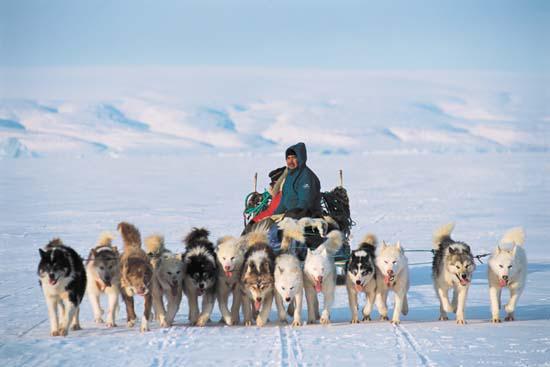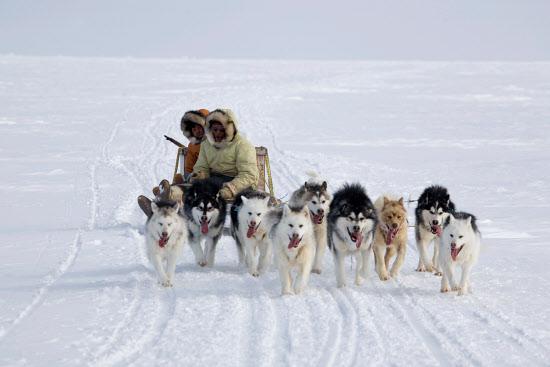The first image is the image on the left, the second image is the image on the right. Given the left and right images, does the statement "There are dogs resting." hold true? Answer yes or no. No. The first image is the image on the left, the second image is the image on the right. Assess this claim about the two images: "Some of the dogs are sitting.". Correct or not? Answer yes or no. No. 